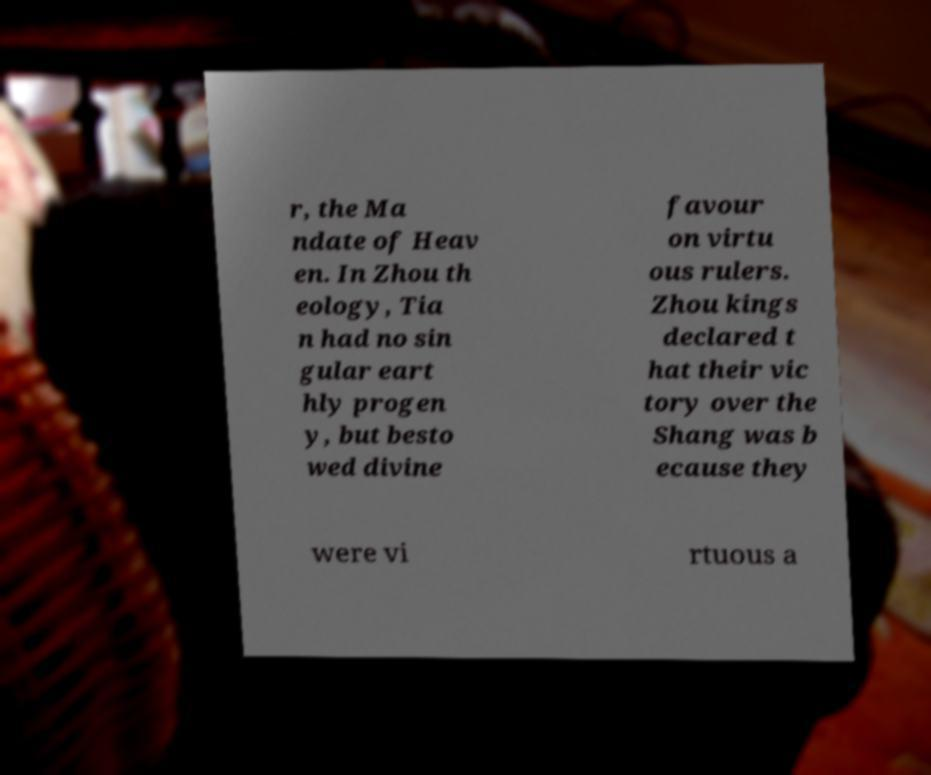Could you assist in decoding the text presented in this image and type it out clearly? r, the Ma ndate of Heav en. In Zhou th eology, Tia n had no sin gular eart hly progen y, but besto wed divine favour on virtu ous rulers. Zhou kings declared t hat their vic tory over the Shang was b ecause they were vi rtuous a 